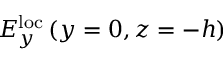<formula> <loc_0><loc_0><loc_500><loc_500>E _ { y } ^ { l o c } \left ( y = 0 , z = - h \right )</formula> 